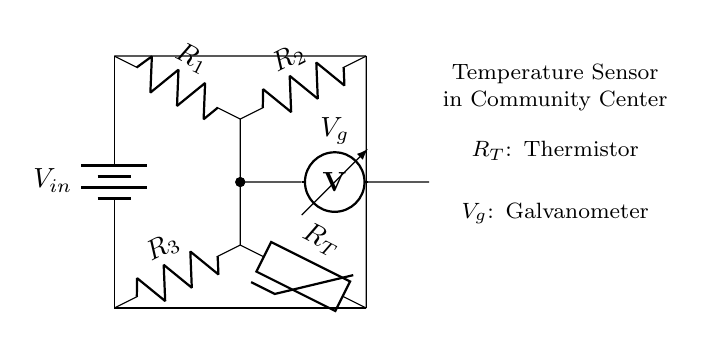What is the input voltage of the circuit? The input voltage, denoted as V_in, is the voltage source connected from the top of the circuit to the bottom. It provides the necessary energy to the circuit, enabling current flow through the resistors and thermistor.
Answer: V_in Which component measures the voltage difference? The component that measures the voltage difference across the bridge is identified as the voltmeter (V_g), located between the two branches of the Wheatstone bridge. It indicates whether the bridge is balanced or unbalanced based on the voltage it reads.
Answer: Voltmeter What type of sensor is used in this circuit? The sensor used in this circuit is a thermistor (R_T), which is a type of resistor whose resistance varies significantly with temperature changes. This component is essential for monitoring temperature in the community center.
Answer: Thermistor What happens when the circuit is balanced? When the Wheatstone bridge circuit is balanced, the voltage across the galvanometer (V_g) will be zero, indicating that the ratios of the resistances in the two branches are equal. This enables accurate temperature measurements.
Answer: Zero voltage What role does the variable resistor play? The variable resistor in the Wheatstone bridge is used to adjust the balance of the circuit. In this configuration, the resistors R_1 and R_2 can be selected or varied to calibrate the measurement system such that adjustments can support accurate readings of temperature changes.
Answer: Calibration What is the significance of R_T in this circuit? R_T, the thermistor, plays a critical role in the circuit by changing its resistance with temperature fluctuations. This variability is what allows for monitoring temperature in real-time within the community center. Therefore, its precise properties are crucial for accurate readings.
Answer: Temperature monitoring 